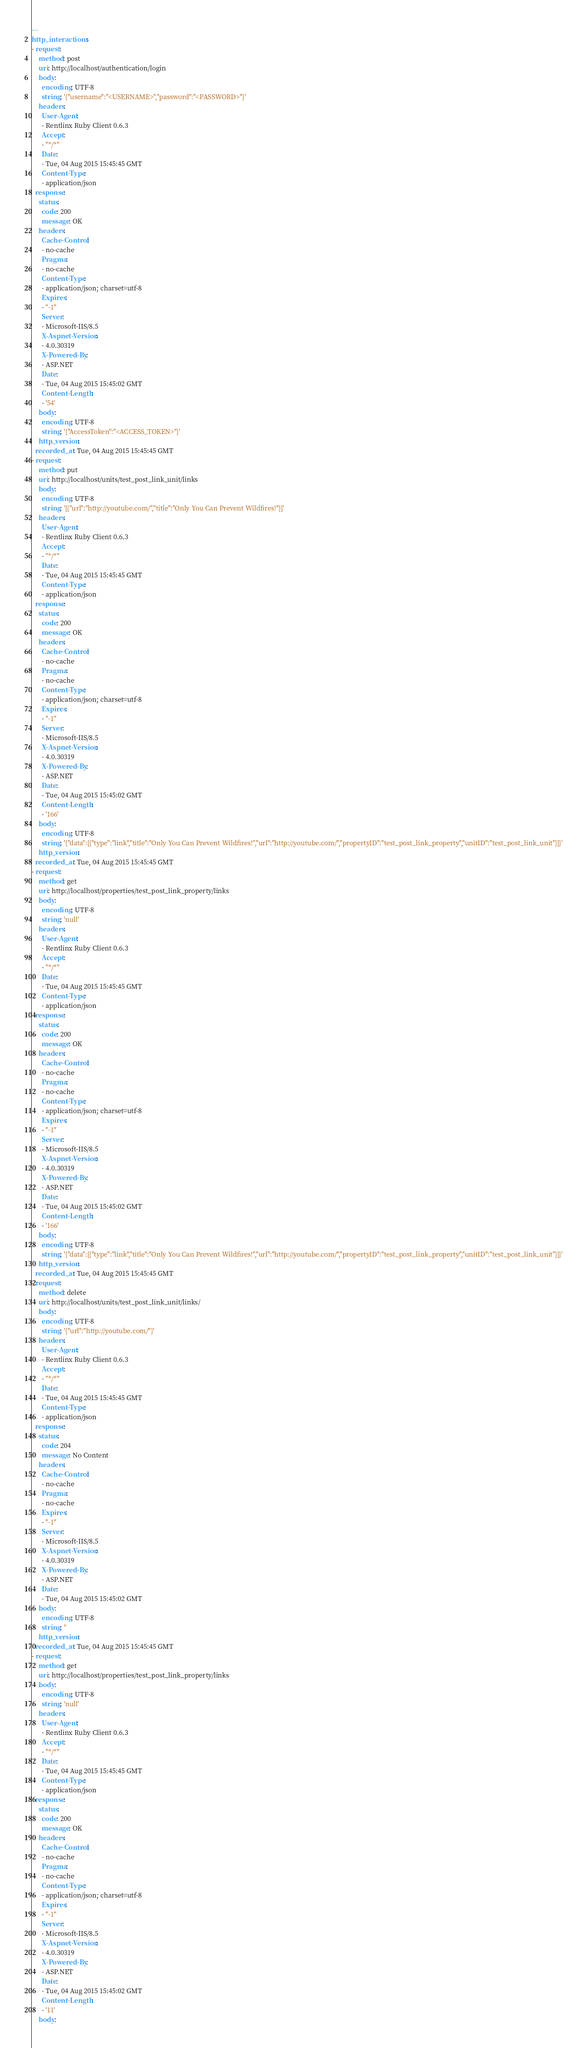Convert code to text. <code><loc_0><loc_0><loc_500><loc_500><_YAML_>---
http_interactions:
- request:
    method: post
    uri: http://localhost/authentication/login
    body:
      encoding: UTF-8
      string: '{"username":"<USERNAME>","password":"<PASSWORD>"}'
    headers:
      User-Agent:
      - Rentlinx Ruby Client 0.6.3
      Accept:
      - "*/*"
      Date:
      - Tue, 04 Aug 2015 15:45:45 GMT
      Content-Type:
      - application/json
  response:
    status:
      code: 200
      message: OK
    headers:
      Cache-Control:
      - no-cache
      Pragma:
      - no-cache
      Content-Type:
      - application/json; charset=utf-8
      Expires:
      - "-1"
      Server:
      - Microsoft-IIS/8.5
      X-Aspnet-Version:
      - 4.0.30319
      X-Powered-By:
      - ASP.NET
      Date:
      - Tue, 04 Aug 2015 15:45:02 GMT
      Content-Length:
      - '54'
    body:
      encoding: UTF-8
      string: '{"AccessToken":"<ACCESS_TOKEN>"}'
    http_version: 
  recorded_at: Tue, 04 Aug 2015 15:45:45 GMT
- request:
    method: put
    uri: http://localhost/units/test_post_link_unit/links
    body:
      encoding: UTF-8
      string: '[{"url":"http://youtube.com/","title":"Only You Can Prevent Wildfires!"}]'
    headers:
      User-Agent:
      - Rentlinx Ruby Client 0.6.3
      Accept:
      - "*/*"
      Date:
      - Tue, 04 Aug 2015 15:45:45 GMT
      Content-Type:
      - application/json
  response:
    status:
      code: 200
      message: OK
    headers:
      Cache-Control:
      - no-cache
      Pragma:
      - no-cache
      Content-Type:
      - application/json; charset=utf-8
      Expires:
      - "-1"
      Server:
      - Microsoft-IIS/8.5
      X-Aspnet-Version:
      - 4.0.30319
      X-Powered-By:
      - ASP.NET
      Date:
      - Tue, 04 Aug 2015 15:45:02 GMT
      Content-Length:
      - '166'
    body:
      encoding: UTF-8
      string: '{"data":[{"type":"link","title":"Only You Can Prevent Wildfires!","url":"http://youtube.com/","propertyID":"test_post_link_property","unitID":"test_post_link_unit"}]}'
    http_version: 
  recorded_at: Tue, 04 Aug 2015 15:45:45 GMT
- request:
    method: get
    uri: http://localhost/properties/test_post_link_property/links
    body:
      encoding: UTF-8
      string: 'null'
    headers:
      User-Agent:
      - Rentlinx Ruby Client 0.6.3
      Accept:
      - "*/*"
      Date:
      - Tue, 04 Aug 2015 15:45:45 GMT
      Content-Type:
      - application/json
  response:
    status:
      code: 200
      message: OK
    headers:
      Cache-Control:
      - no-cache
      Pragma:
      - no-cache
      Content-Type:
      - application/json; charset=utf-8
      Expires:
      - "-1"
      Server:
      - Microsoft-IIS/8.5
      X-Aspnet-Version:
      - 4.0.30319
      X-Powered-By:
      - ASP.NET
      Date:
      - Tue, 04 Aug 2015 15:45:02 GMT
      Content-Length:
      - '166'
    body:
      encoding: UTF-8
      string: '{"data":[{"type":"link","title":"Only You Can Prevent Wildfires!","url":"http://youtube.com/","propertyID":"test_post_link_property","unitID":"test_post_link_unit"}]}'
    http_version: 
  recorded_at: Tue, 04 Aug 2015 15:45:45 GMT
- request:
    method: delete
    uri: http://localhost/units/test_post_link_unit/links/
    body:
      encoding: UTF-8
      string: '{"url":"http://youtube.com/"}'
    headers:
      User-Agent:
      - Rentlinx Ruby Client 0.6.3
      Accept:
      - "*/*"
      Date:
      - Tue, 04 Aug 2015 15:45:45 GMT
      Content-Type:
      - application/json
  response:
    status:
      code: 204
      message: No Content
    headers:
      Cache-Control:
      - no-cache
      Pragma:
      - no-cache
      Expires:
      - "-1"
      Server:
      - Microsoft-IIS/8.5
      X-Aspnet-Version:
      - 4.0.30319
      X-Powered-By:
      - ASP.NET
      Date:
      - Tue, 04 Aug 2015 15:45:02 GMT
    body:
      encoding: UTF-8
      string: ''
    http_version: 
  recorded_at: Tue, 04 Aug 2015 15:45:45 GMT
- request:
    method: get
    uri: http://localhost/properties/test_post_link_property/links
    body:
      encoding: UTF-8
      string: 'null'
    headers:
      User-Agent:
      - Rentlinx Ruby Client 0.6.3
      Accept:
      - "*/*"
      Date:
      - Tue, 04 Aug 2015 15:45:45 GMT
      Content-Type:
      - application/json
  response:
    status:
      code: 200
      message: OK
    headers:
      Cache-Control:
      - no-cache
      Pragma:
      - no-cache
      Content-Type:
      - application/json; charset=utf-8
      Expires:
      - "-1"
      Server:
      - Microsoft-IIS/8.5
      X-Aspnet-Version:
      - 4.0.30319
      X-Powered-By:
      - ASP.NET
      Date:
      - Tue, 04 Aug 2015 15:45:02 GMT
      Content-Length:
      - '11'
    body:</code> 